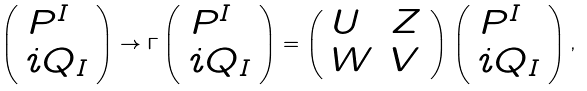Convert formula to latex. <formula><loc_0><loc_0><loc_500><loc_500>\left ( \begin{array} { l } { { P ^ { I } } } \\ { { i Q _ { I } } } \end{array} \right ) \rightarrow \Gamma \left ( \begin{array} { l } { { P ^ { I } } } \\ { { i Q _ { I } } } \end{array} \right ) = \left ( \begin{array} { l l } { U } & { Z } \\ { W } & { V } \end{array} \right ) \left ( \begin{array} { l } { { P ^ { I } } } \\ { { i Q _ { I } } } \end{array} \right ) ,</formula> 